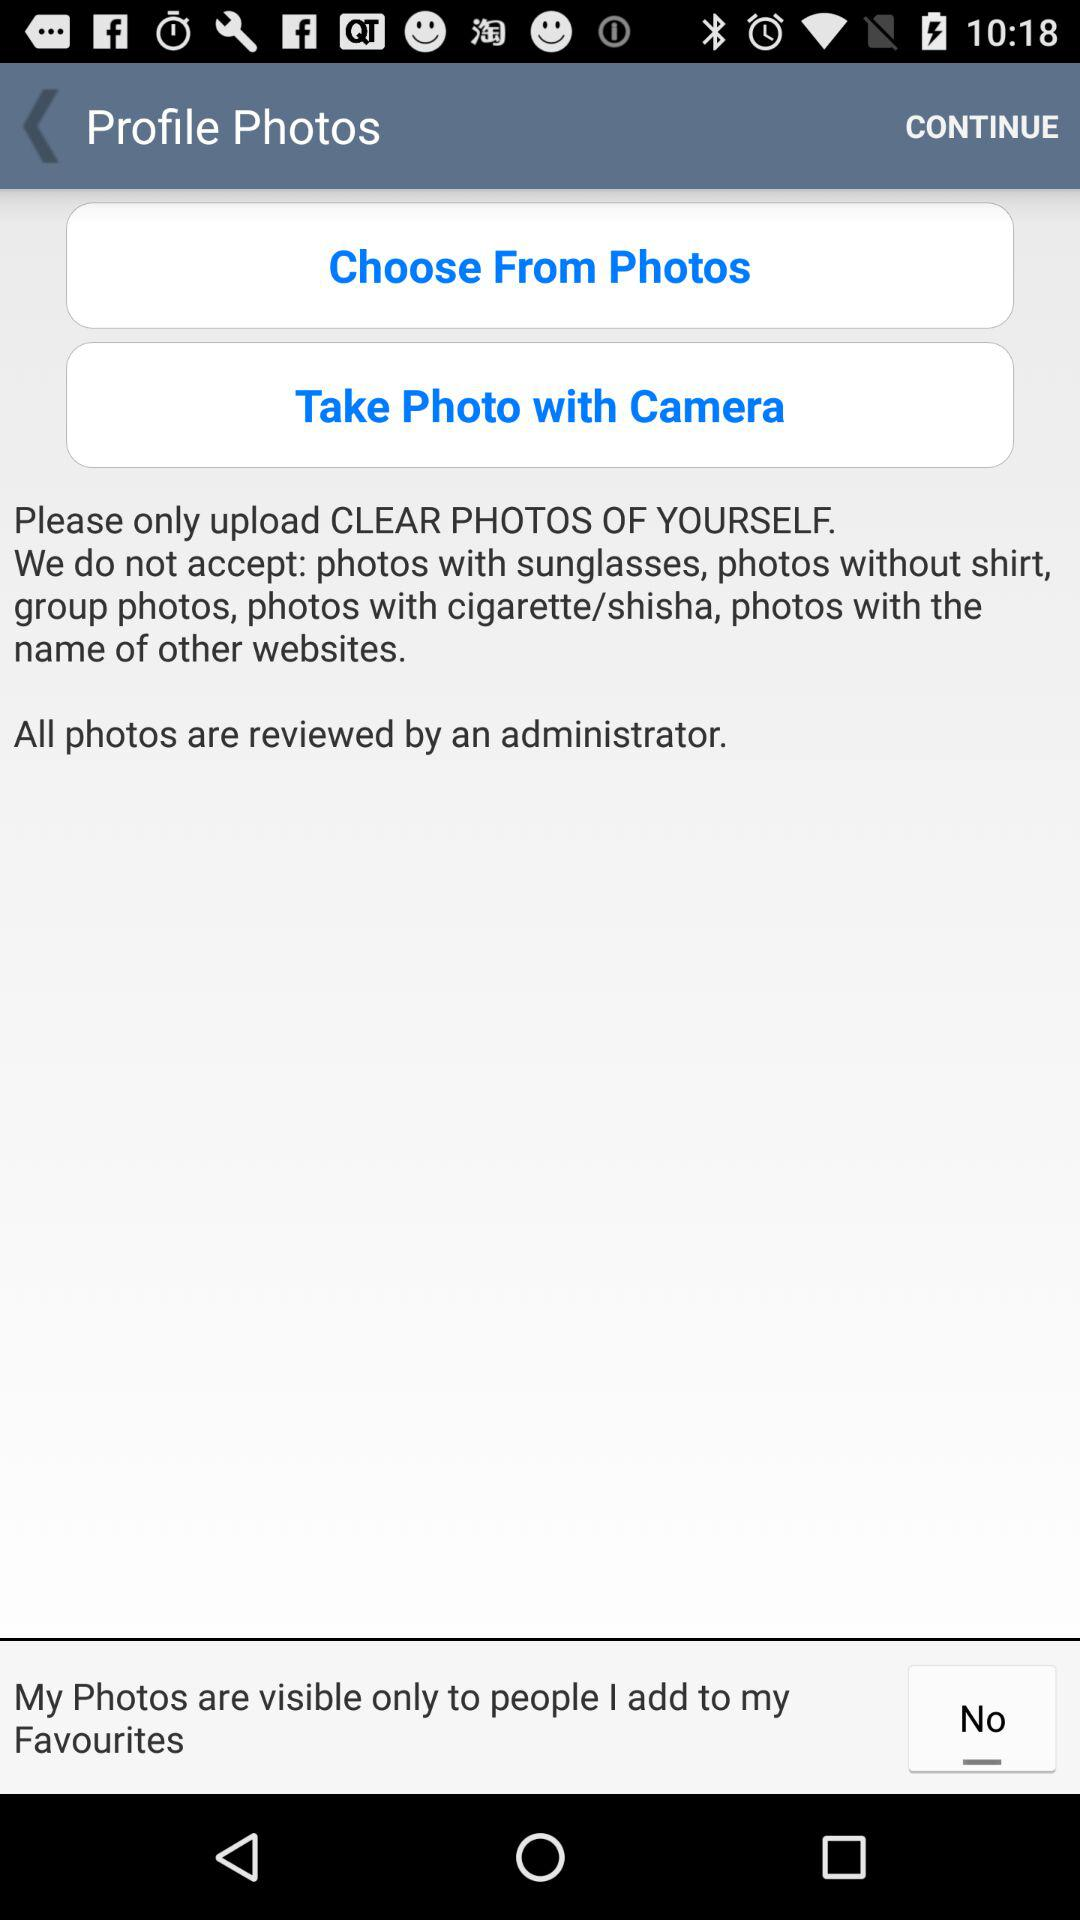What types of photos should be uploaded? The photos should be "CLEAR PHOTOS OF YOURSELF". 